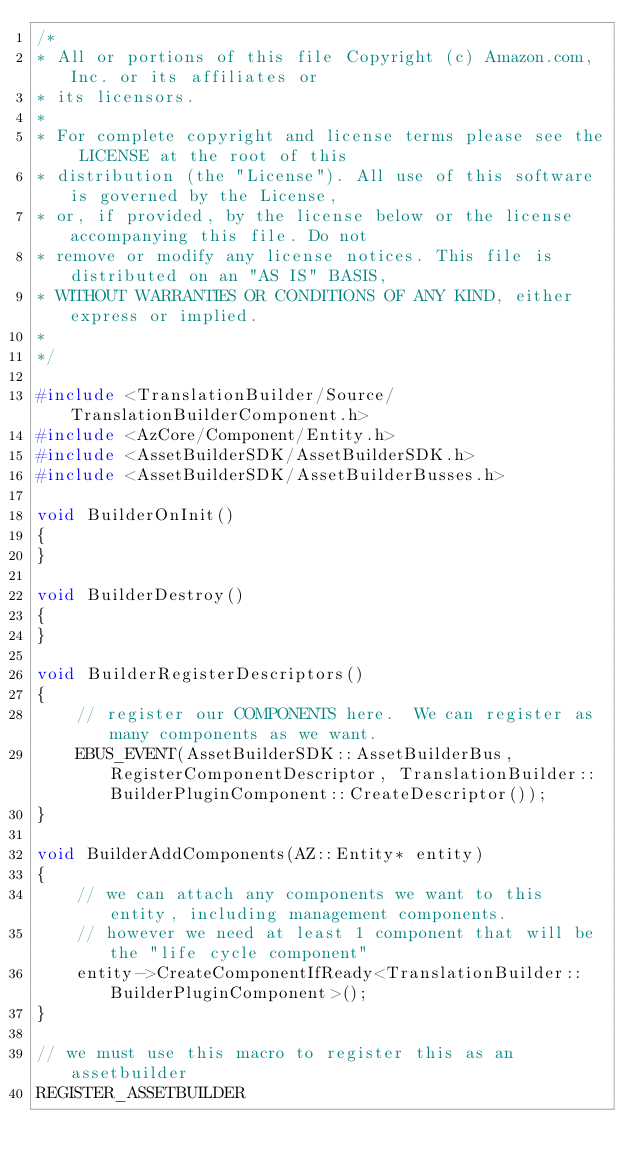Convert code to text. <code><loc_0><loc_0><loc_500><loc_500><_C++_>/*
* All or portions of this file Copyright (c) Amazon.com, Inc. or its affiliates or
* its licensors.
*
* For complete copyright and license terms please see the LICENSE at the root of this
* distribution (the "License"). All use of this software is governed by the License,
* or, if provided, by the license below or the license accompanying this file. Do not
* remove or modify any license notices. This file is distributed on an "AS IS" BASIS,
* WITHOUT WARRANTIES OR CONDITIONS OF ANY KIND, either express or implied.
*
*/

#include <TranslationBuilder/Source/TranslationBuilderComponent.h>
#include <AzCore/Component/Entity.h>
#include <AssetBuilderSDK/AssetBuilderSDK.h>
#include <AssetBuilderSDK/AssetBuilderBusses.h>

void BuilderOnInit()
{
}

void BuilderDestroy()
{
}

void BuilderRegisterDescriptors()
{
    // register our COMPONENTS here.  We can register as many components as we want.
    EBUS_EVENT(AssetBuilderSDK::AssetBuilderBus, RegisterComponentDescriptor, TranslationBuilder::BuilderPluginComponent::CreateDescriptor());
}

void BuilderAddComponents(AZ::Entity* entity)
{
    // we can attach any components we want to this entity, including management components.
    // however we need at least 1 component that will be the "life cycle component"
    entity->CreateComponentIfReady<TranslationBuilder::BuilderPluginComponent>();
}

// we must use this macro to register this as an assetbuilder
REGISTER_ASSETBUILDER
</code> 